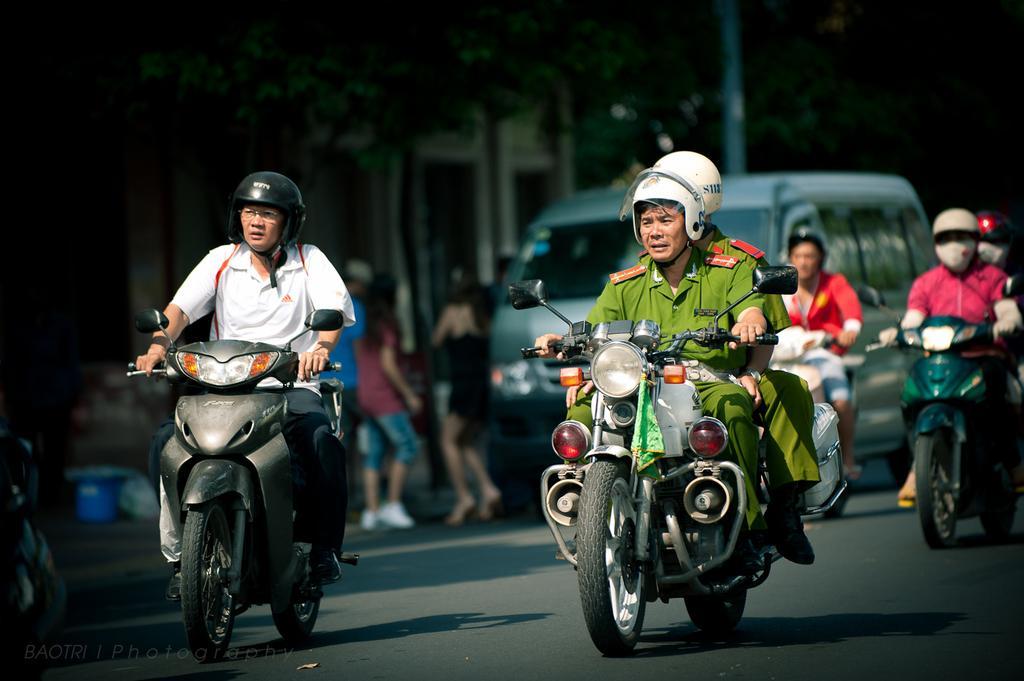Can you describe this image briefly? In this picture there is a man who is wearing a white shirt and a helmet on his head and is riding a scooter. There is also another man who is in the green and wearing a helmet on his head riding a motor bike. There is another man sitting at the back of him. There is a vehicle at the background. There is a tree and a pole at the background. There are two girls who are standing on the road. 